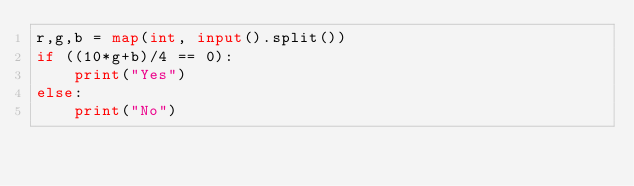<code> <loc_0><loc_0><loc_500><loc_500><_Python_>r,g,b = map(int, input().split())
if ((10*g+b)/4 == 0):
    print("Yes")
else:
    print("No")</code> 